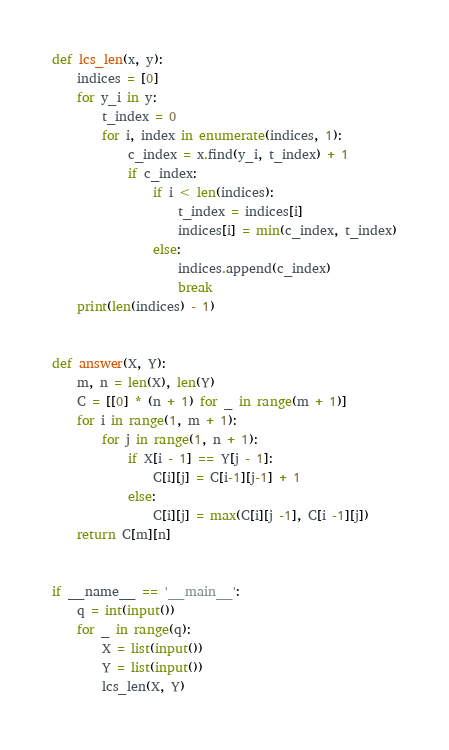Convert code to text. <code><loc_0><loc_0><loc_500><loc_500><_Python_>def lcs_len(x, y):
    indices = [0]
    for y_i in y:
        t_index = 0
        for i, index in enumerate(indices, 1):
            c_index = x.find(y_i, t_index) + 1
            if c_index:
                if i < len(indices):
                    t_index = indices[i]
                    indices[i] = min(c_index, t_index)
                else:
                    indices.append(c_index)
                    break
    print(len(indices) - 1)


def answer(X, Y):
    m, n = len(X), len(Y)
    C = [[0] * (n + 1) for _ in range(m + 1)]
    for i in range(1, m + 1):
        for j in range(1, n + 1):
            if X[i - 1] == Y[j - 1]:
                C[i][j] = C[i-1][j-1] + 1
            else:
                C[i][j] = max(C[i][j -1], C[i -1][j])
    return C[m][n]


if __name__ == '__main__':
    q = int(input())
    for _ in range(q):
        X = list(input())
        Y = list(input())
        lcs_len(X, Y)</code> 